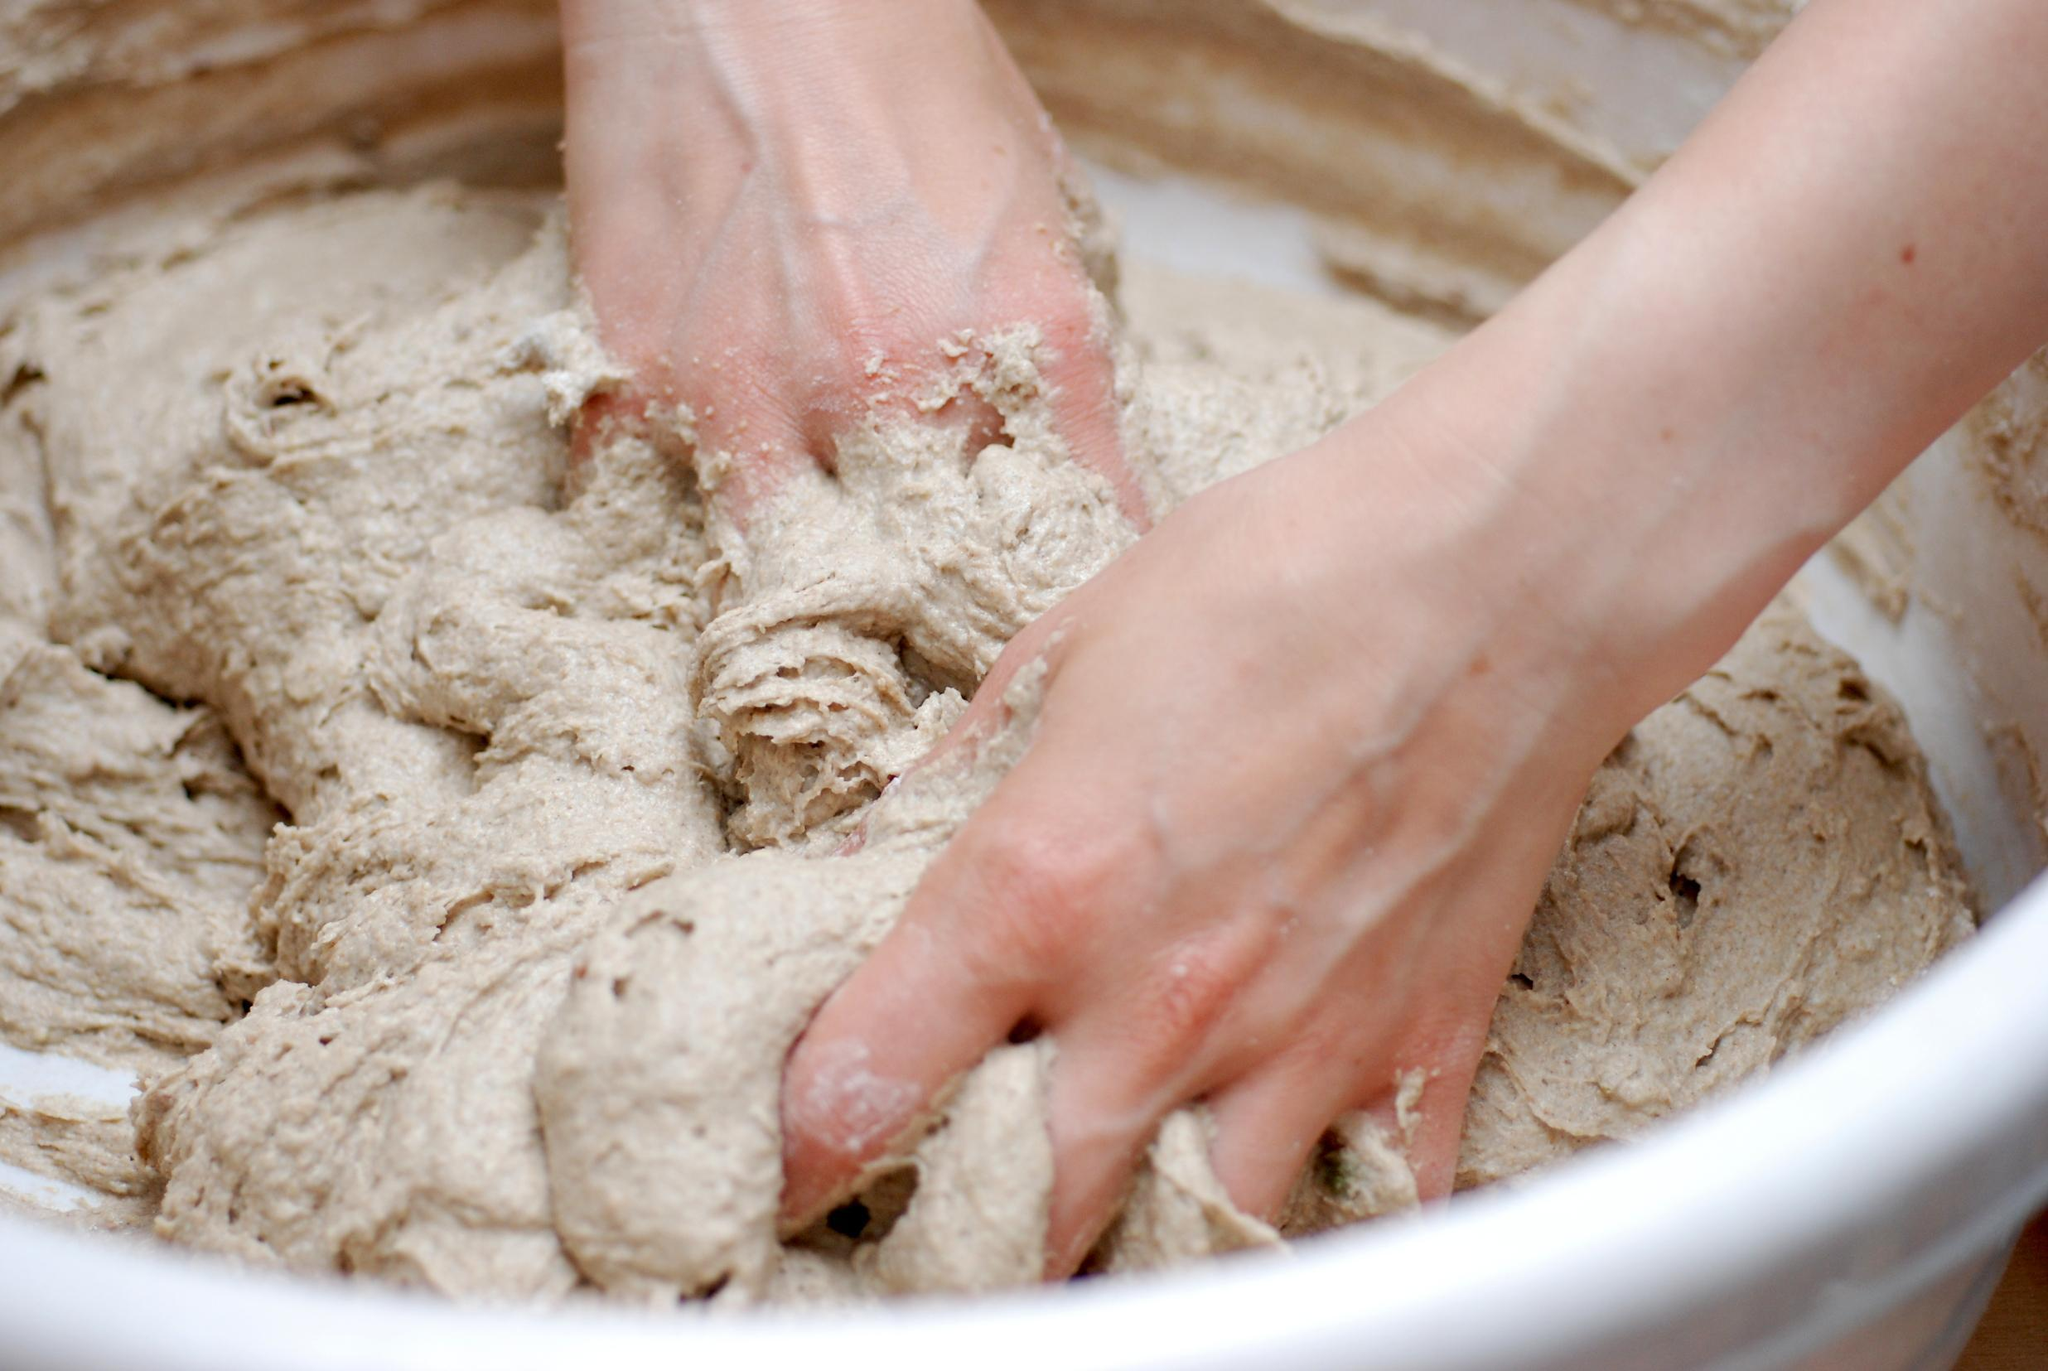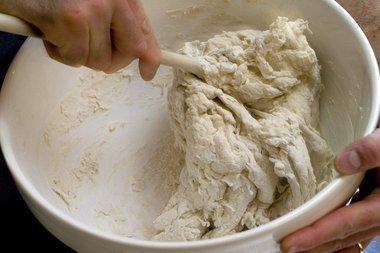The first image is the image on the left, the second image is the image on the right. Examine the images to the left and right. Is the description "Exactly one ball of dough is on a table." accurate? Answer yes or no. No. The first image is the image on the left, the second image is the image on the right. For the images shown, is this caption "One of the images shows a pair of hands kneading dough and the other image shows a ball of dough in a bowl." true? Answer yes or no. No. 